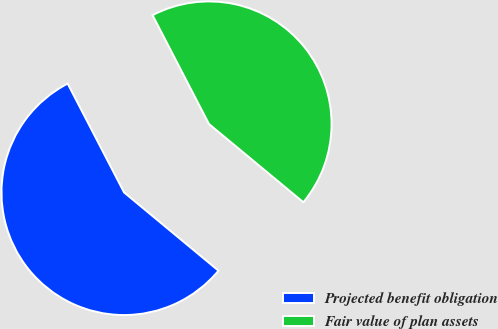<chart> <loc_0><loc_0><loc_500><loc_500><pie_chart><fcel>Projected benefit obligation<fcel>Fair value of plan assets<nl><fcel>56.37%<fcel>43.63%<nl></chart> 